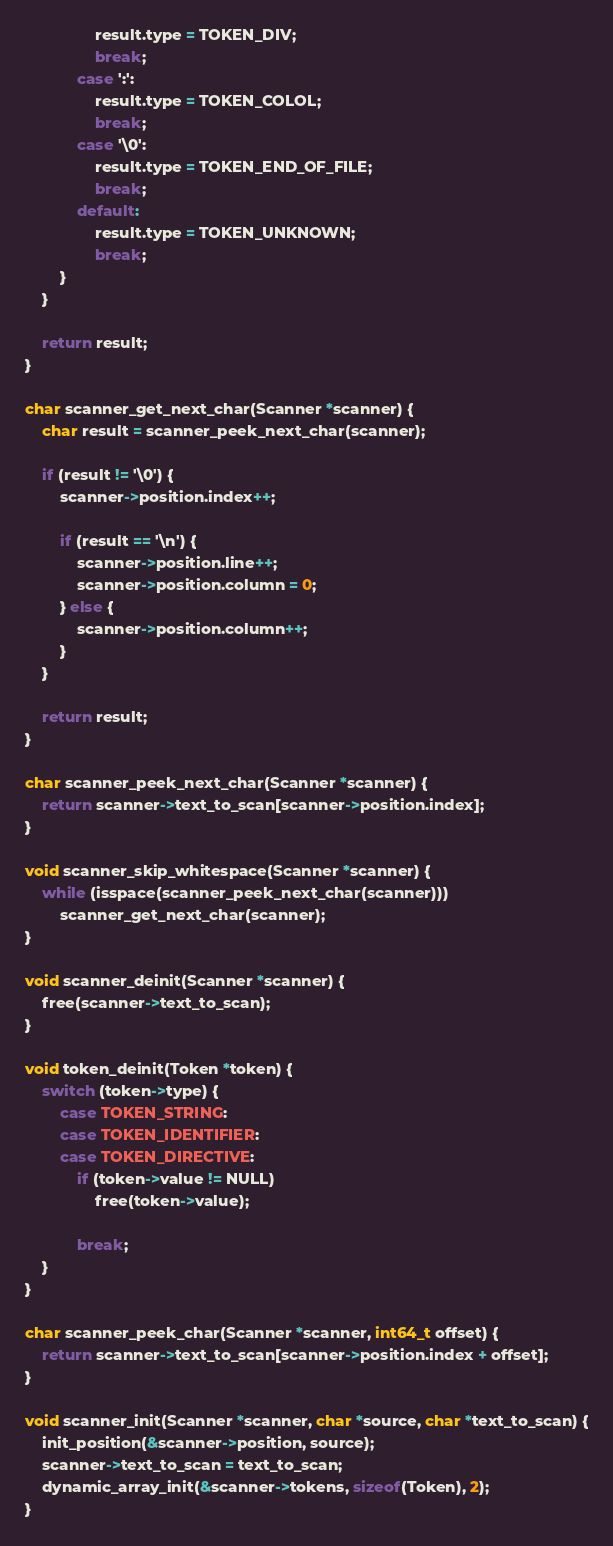<code> <loc_0><loc_0><loc_500><loc_500><_C_>                result.type = TOKEN_DIV;
                break;
            case ':':
                result.type = TOKEN_COLOL;
                break;
            case '\0':
                result.type = TOKEN_END_OF_FILE;
                break;
            default: 
                result.type = TOKEN_UNKNOWN;
                break;
        }
    }

    return result;
}

char scanner_get_next_char(Scanner *scanner) {
    char result = scanner_peek_next_char(scanner);

    if (result != '\0') {
        scanner->position.index++;

        if (result == '\n') {
            scanner->position.line++;
            scanner->position.column = 0;
        } else {
            scanner->position.column++;
        }
    }

    return result;
}

char scanner_peek_next_char(Scanner *scanner) {
    return scanner->text_to_scan[scanner->position.index];
}

void scanner_skip_whitespace(Scanner *scanner) {
    while (isspace(scanner_peek_next_char(scanner)))
        scanner_get_next_char(scanner);
}

void scanner_deinit(Scanner *scanner) {
    free(scanner->text_to_scan);
}

void token_deinit(Token *token) {
    switch (token->type) {
        case TOKEN_STRING:
        case TOKEN_IDENTIFIER:
        case TOKEN_DIRECTIVE:
            if (token->value != NULL)
                free(token->value);

            break;
    }
}

char scanner_peek_char(Scanner *scanner, int64_t offset) {
    return scanner->text_to_scan[scanner->position.index + offset];
}

void scanner_init(Scanner *scanner, char *source, char *text_to_scan) {
    init_position(&scanner->position, source);
    scanner->text_to_scan = text_to_scan;
    dynamic_array_init(&scanner->tokens, sizeof(Token), 2);
}
</code> 